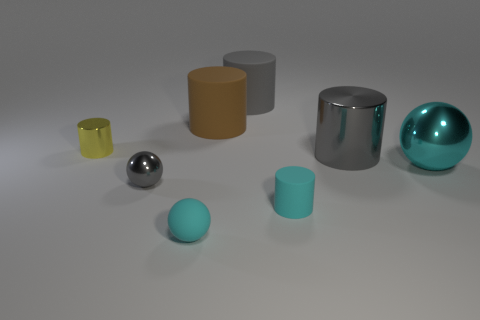There is a big matte object that is in front of the cylinder behind the large brown rubber cylinder; what shape is it?
Offer a very short reply. Cylinder. Is the material of the yellow object the same as the tiny cylinder to the right of the gray metal ball?
Your answer should be compact. No. There is a metallic thing that is the same color as the tiny matte sphere; what shape is it?
Offer a terse response. Sphere. What number of other shiny objects have the same size as the yellow object?
Ensure brevity in your answer.  1. Are there fewer cyan matte balls that are in front of the big metallic ball than large gray objects?
Keep it short and to the point. Yes. There is a large cyan thing; how many large cylinders are right of it?
Provide a short and direct response. 0. There is a gray cylinder behind the large cylinder to the right of the large gray cylinder to the left of the small rubber cylinder; how big is it?
Keep it short and to the point. Large. Do the tiny gray metal object and the gray metal object behind the gray shiny sphere have the same shape?
Your response must be concise. No. What size is the yellow thing that is the same material as the big cyan ball?
Provide a succinct answer. Small. Is there anything else of the same color as the large metal sphere?
Ensure brevity in your answer.  Yes. 